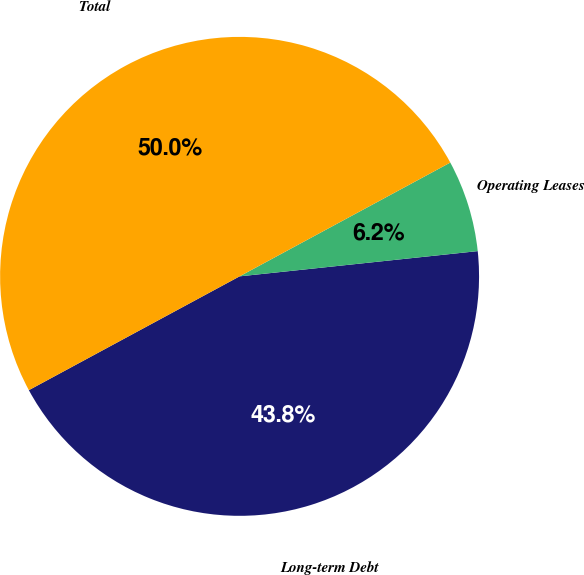Convert chart to OTSL. <chart><loc_0><loc_0><loc_500><loc_500><pie_chart><fcel>Long-term Debt<fcel>Operating Leases<fcel>Total<nl><fcel>43.8%<fcel>6.2%<fcel>50.0%<nl></chart> 